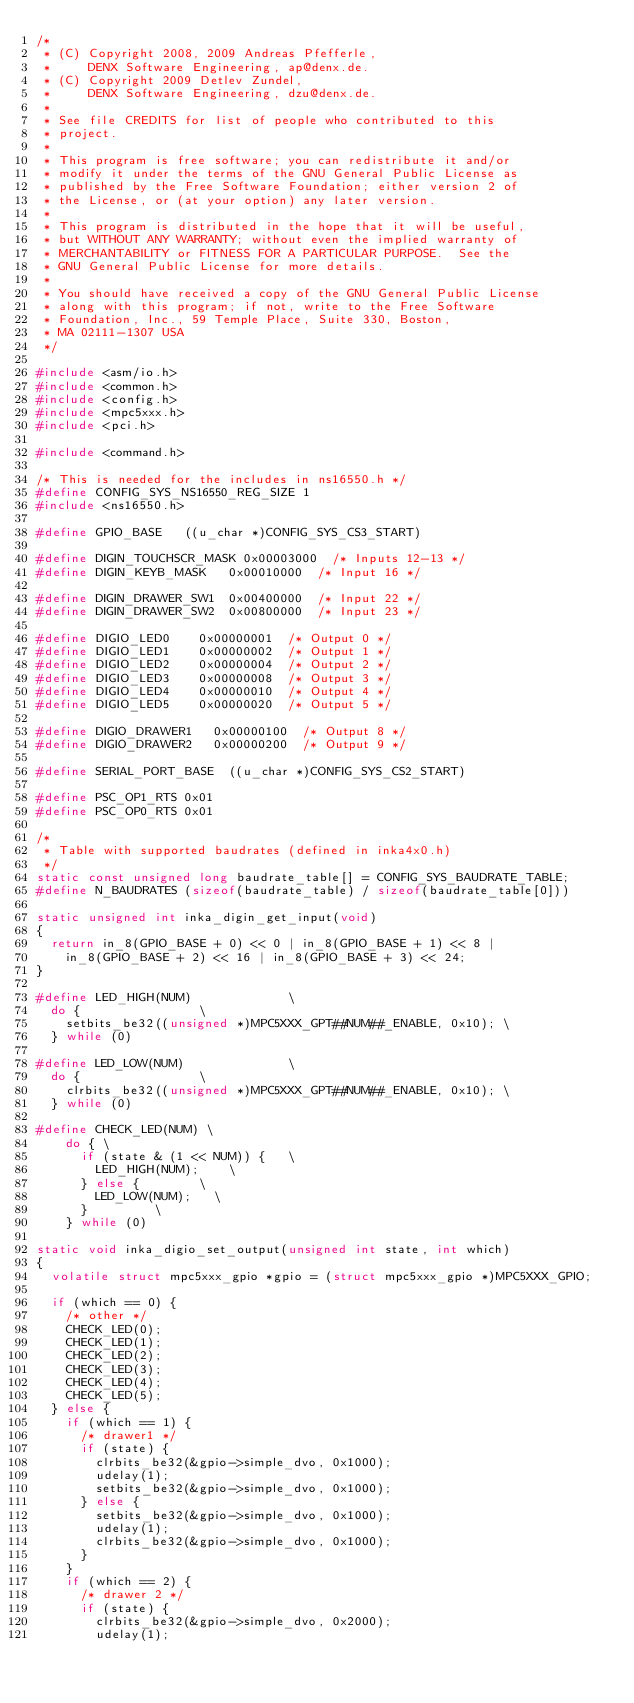Convert code to text. <code><loc_0><loc_0><loc_500><loc_500><_C_>/*
 * (C) Copyright 2008, 2009 Andreas Pfefferle,
 *     DENX Software Engineering, ap@denx.de.
 * (C) Copyright 2009 Detlev Zundel,
 *     DENX Software Engineering, dzu@denx.de.
 *
 * See file CREDITS for list of people who contributed to this
 * project.
 *
 * This program is free software; you can redistribute it and/or
 * modify it under the terms of the GNU General Public License as
 * published by the Free Software Foundation; either version 2 of
 * the License, or (at your option) any later version.
 *
 * This program is distributed in the hope that it will be useful,
 * but WITHOUT ANY WARRANTY; without even the implied warranty of
 * MERCHANTABILITY or FITNESS FOR A PARTICULAR PURPOSE.  See the
 * GNU General Public License for more details.
 *
 * You should have received a copy of the GNU General Public License
 * along with this program; if not, write to the Free Software
 * Foundation, Inc., 59 Temple Place, Suite 330, Boston,
 * MA 02111-1307 USA
 */

#include <asm/io.h>
#include <common.h>
#include <config.h>
#include <mpc5xxx.h>
#include <pci.h>

#include <command.h>

/* This is needed for the includes in ns16550.h */
#define CONFIG_SYS_NS16550_REG_SIZE 1
#include <ns16550.h>

#define GPIO_BASE		((u_char *)CONFIG_SYS_CS3_START)

#define DIGIN_TOUCHSCR_MASK	0x00003000	/* Inputs 12-13 */
#define DIGIN_KEYB_MASK		0x00010000	/* Input 16 */

#define DIGIN_DRAWER_SW1	0x00400000	/* Input 22 */
#define DIGIN_DRAWER_SW2	0x00800000	/* Input 23 */

#define DIGIO_LED0		0x00000001	/* Output 0 */
#define DIGIO_LED1		0x00000002	/* Output 1 */
#define DIGIO_LED2		0x00000004	/* Output 2 */
#define DIGIO_LED3		0x00000008	/* Output 3 */
#define DIGIO_LED4		0x00000010	/* Output 4 */
#define DIGIO_LED5		0x00000020	/* Output 5 */

#define DIGIO_DRAWER1		0x00000100	/* Output 8 */
#define DIGIO_DRAWER2		0x00000200	/* Output 9 */

#define SERIAL_PORT_BASE	((u_char *)CONFIG_SYS_CS2_START)

#define PSC_OP1_RTS	0x01
#define PSC_OP0_RTS	0x01

/*
 * Table with supported baudrates (defined in inka4x0.h)
 */
static const unsigned long baudrate_table[] = CONFIG_SYS_BAUDRATE_TABLE;
#define	N_BAUDRATES (sizeof(baudrate_table) / sizeof(baudrate_table[0]))

static unsigned int inka_digin_get_input(void)
{
	return in_8(GPIO_BASE + 0) << 0 | in_8(GPIO_BASE + 1) << 8 |
		in_8(GPIO_BASE + 2) << 16 | in_8(GPIO_BASE + 3) << 24;
}

#define LED_HIGH(NUM)							\
	do {								\
		setbits_be32((unsigned *)MPC5XXX_GPT##NUM##_ENABLE, 0x10); \
	} while (0)

#define LED_LOW(NUM)							\
	do {								\
		clrbits_be32((unsigned *)MPC5XXX_GPT##NUM##_ENABLE, 0x10); \
	} while (0)

#define CHECK_LED(NUM) \
    do { \
	    if (state & (1 << NUM)) {		\
		    LED_HIGH(NUM);		\
	    } else {				\
		    LED_LOW(NUM);		\
	    }					\
    } while (0)

static void inka_digio_set_output(unsigned int state, int which)
{
	volatile struct mpc5xxx_gpio *gpio = (struct mpc5xxx_gpio *)MPC5XXX_GPIO;

	if (which == 0) {
		/* other */
		CHECK_LED(0);
		CHECK_LED(1);
		CHECK_LED(2);
		CHECK_LED(3);
		CHECK_LED(4);
		CHECK_LED(5);
	} else {
		if (which == 1) {
			/* drawer1 */
			if (state) {
				clrbits_be32(&gpio->simple_dvo, 0x1000);
				udelay(1);
				setbits_be32(&gpio->simple_dvo, 0x1000);
			} else {
				setbits_be32(&gpio->simple_dvo, 0x1000);
				udelay(1);
				clrbits_be32(&gpio->simple_dvo, 0x1000);
			}
		}
		if (which == 2) {
			/* drawer 2 */
			if (state) {
				clrbits_be32(&gpio->simple_dvo, 0x2000);
				udelay(1);</code> 